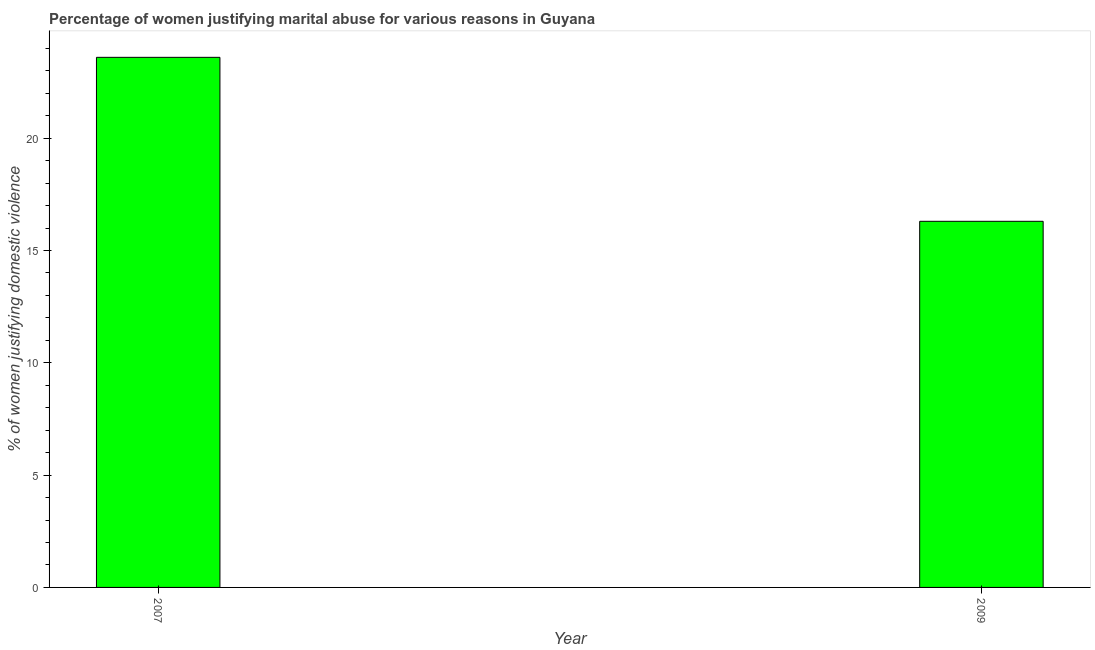Does the graph contain any zero values?
Your answer should be compact. No. What is the title of the graph?
Provide a succinct answer. Percentage of women justifying marital abuse for various reasons in Guyana. What is the label or title of the Y-axis?
Your answer should be compact. % of women justifying domestic violence. What is the percentage of women justifying marital abuse in 2009?
Provide a succinct answer. 16.3. Across all years, what is the maximum percentage of women justifying marital abuse?
Keep it short and to the point. 23.6. In which year was the percentage of women justifying marital abuse maximum?
Give a very brief answer. 2007. In which year was the percentage of women justifying marital abuse minimum?
Offer a very short reply. 2009. What is the sum of the percentage of women justifying marital abuse?
Give a very brief answer. 39.9. What is the average percentage of women justifying marital abuse per year?
Give a very brief answer. 19.95. What is the median percentage of women justifying marital abuse?
Offer a very short reply. 19.95. What is the ratio of the percentage of women justifying marital abuse in 2007 to that in 2009?
Give a very brief answer. 1.45. How many bars are there?
Keep it short and to the point. 2. How many years are there in the graph?
Ensure brevity in your answer.  2. What is the % of women justifying domestic violence of 2007?
Provide a succinct answer. 23.6. What is the % of women justifying domestic violence in 2009?
Keep it short and to the point. 16.3. What is the difference between the % of women justifying domestic violence in 2007 and 2009?
Give a very brief answer. 7.3. What is the ratio of the % of women justifying domestic violence in 2007 to that in 2009?
Ensure brevity in your answer.  1.45. 